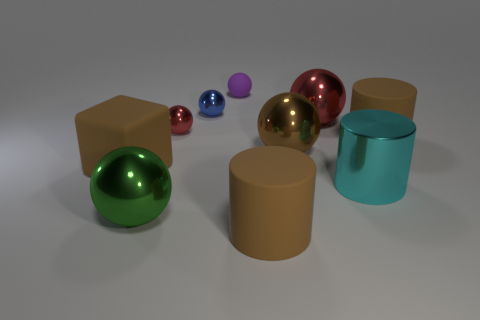Is there any other thing of the same color as the small rubber thing?
Give a very brief answer. No. Do the blue thing and the block have the same size?
Offer a very short reply. No. How big is the brown rubber thing that is to the left of the cyan shiny cylinder and behind the big green metallic ball?
Your response must be concise. Large. How many large spheres have the same material as the small blue object?
Ensure brevity in your answer.  3. What is the shape of the big shiny object that is the same color as the large cube?
Offer a very short reply. Sphere. What is the color of the small rubber ball?
Ensure brevity in your answer.  Purple. There is a red metal object to the left of the big red metal thing; is it the same shape as the small purple rubber thing?
Your response must be concise. Yes. What number of objects are either rubber objects behind the blue sphere or blue shiny objects?
Offer a terse response. 2. Is there a small gray matte object of the same shape as the big cyan shiny thing?
Provide a short and direct response. No. What shape is the red object that is the same size as the purple ball?
Offer a terse response. Sphere. 